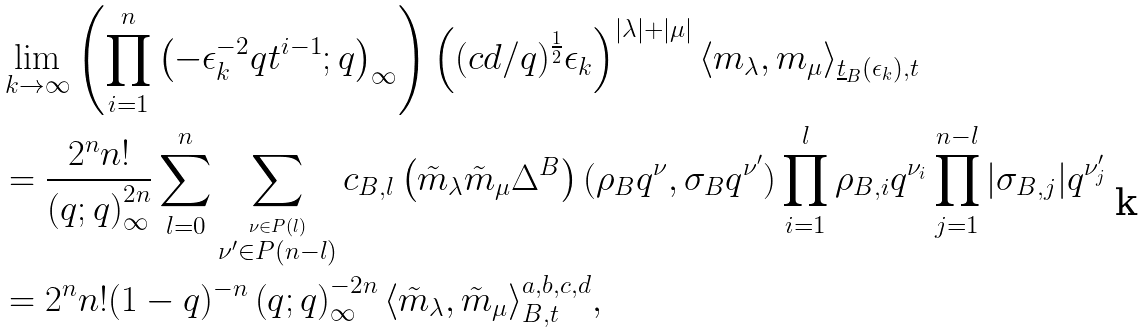Convert formula to latex. <formula><loc_0><loc_0><loc_500><loc_500>& \lim _ { k \rightarrow \infty } \left ( \prod _ { i = 1 } ^ { n } \left ( - \epsilon _ { k } ^ { - 2 } q t ^ { i - 1 } ; q \right ) _ { \infty } \right ) \left ( ( c d / q ) ^ { \frac { 1 } { 2 } } \epsilon _ { k } \right ) ^ { | \lambda | + | \mu | } \langle m _ { \lambda } , m _ { \mu } \rangle _ { \underline { t } _ { B } ( \epsilon _ { k } ) , t } \\ & = \frac { 2 ^ { n } n ! } { \left ( q ; q \right ) _ { \infty } ^ { 2 n } } \sum _ { l = 0 } ^ { n } \sum _ { \stackrel { \nu \in P ( l ) } { \nu ^ { \prime } \in P ( n - l ) } } c _ { B , l } \left ( \tilde { m } _ { \lambda } \tilde { m } _ { \mu } \Delta ^ { B } \right ) ( \rho _ { B } q ^ { \nu } , \sigma _ { B } q ^ { \nu ^ { \prime } } ) \prod _ { i = 1 } ^ { l } \rho _ { B , i } q ^ { \nu _ { i } } \prod _ { j = 1 } ^ { n - l } | \sigma _ { B , j } | q ^ { \nu _ { j } ^ { \prime } } \\ & = 2 ^ { n } n ! ( 1 - q ) ^ { - n } \left ( q ; q \right ) _ { \infty } ^ { - 2 n } \langle \tilde { m } _ { \lambda } , \tilde { m } _ { \mu } \rangle _ { B , t } ^ { a , b , c , d } , \\</formula> 